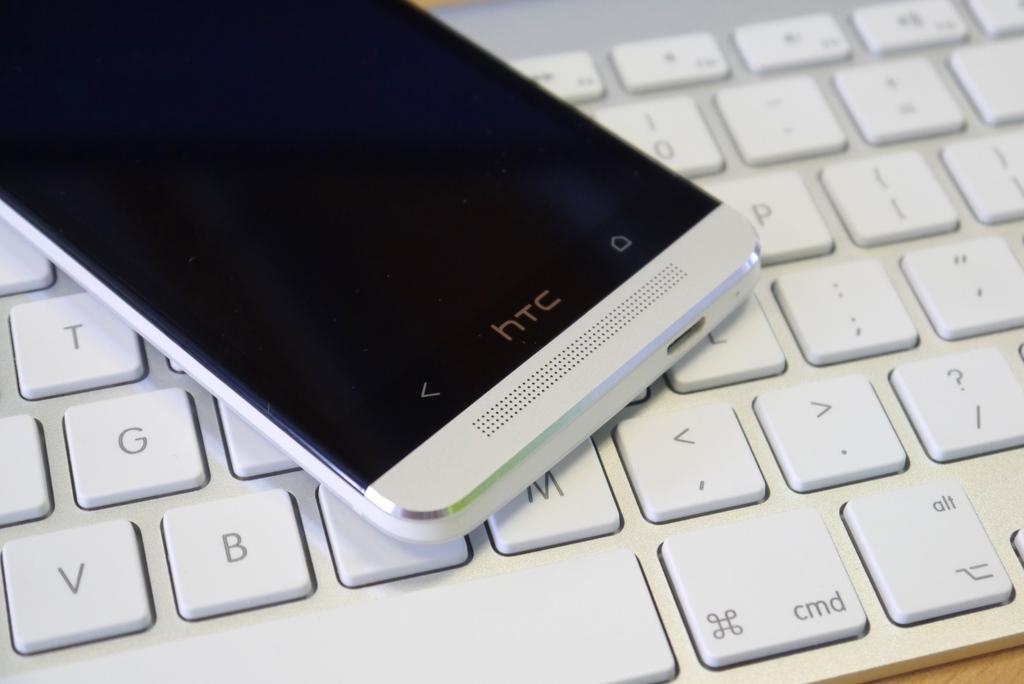What electronic device is visible in the image? There is a mobile phone in the image. What color is the mobile phone? The mobile phone is white in color. What other object can be seen in the image that is also white? There is a keyboard in the image, and it is also white in color. Where are the mobile phone and keyboard located in the image? Both the mobile phone and keyboard are on a table. What type of church can be seen in the background of the image? There is no church visible in the image; it only features a mobile phone and a keyboard on a table. How many ducks are present on the table in the image? There are no ducks present on the table in the image; it only features a mobile phone and a keyboard. 